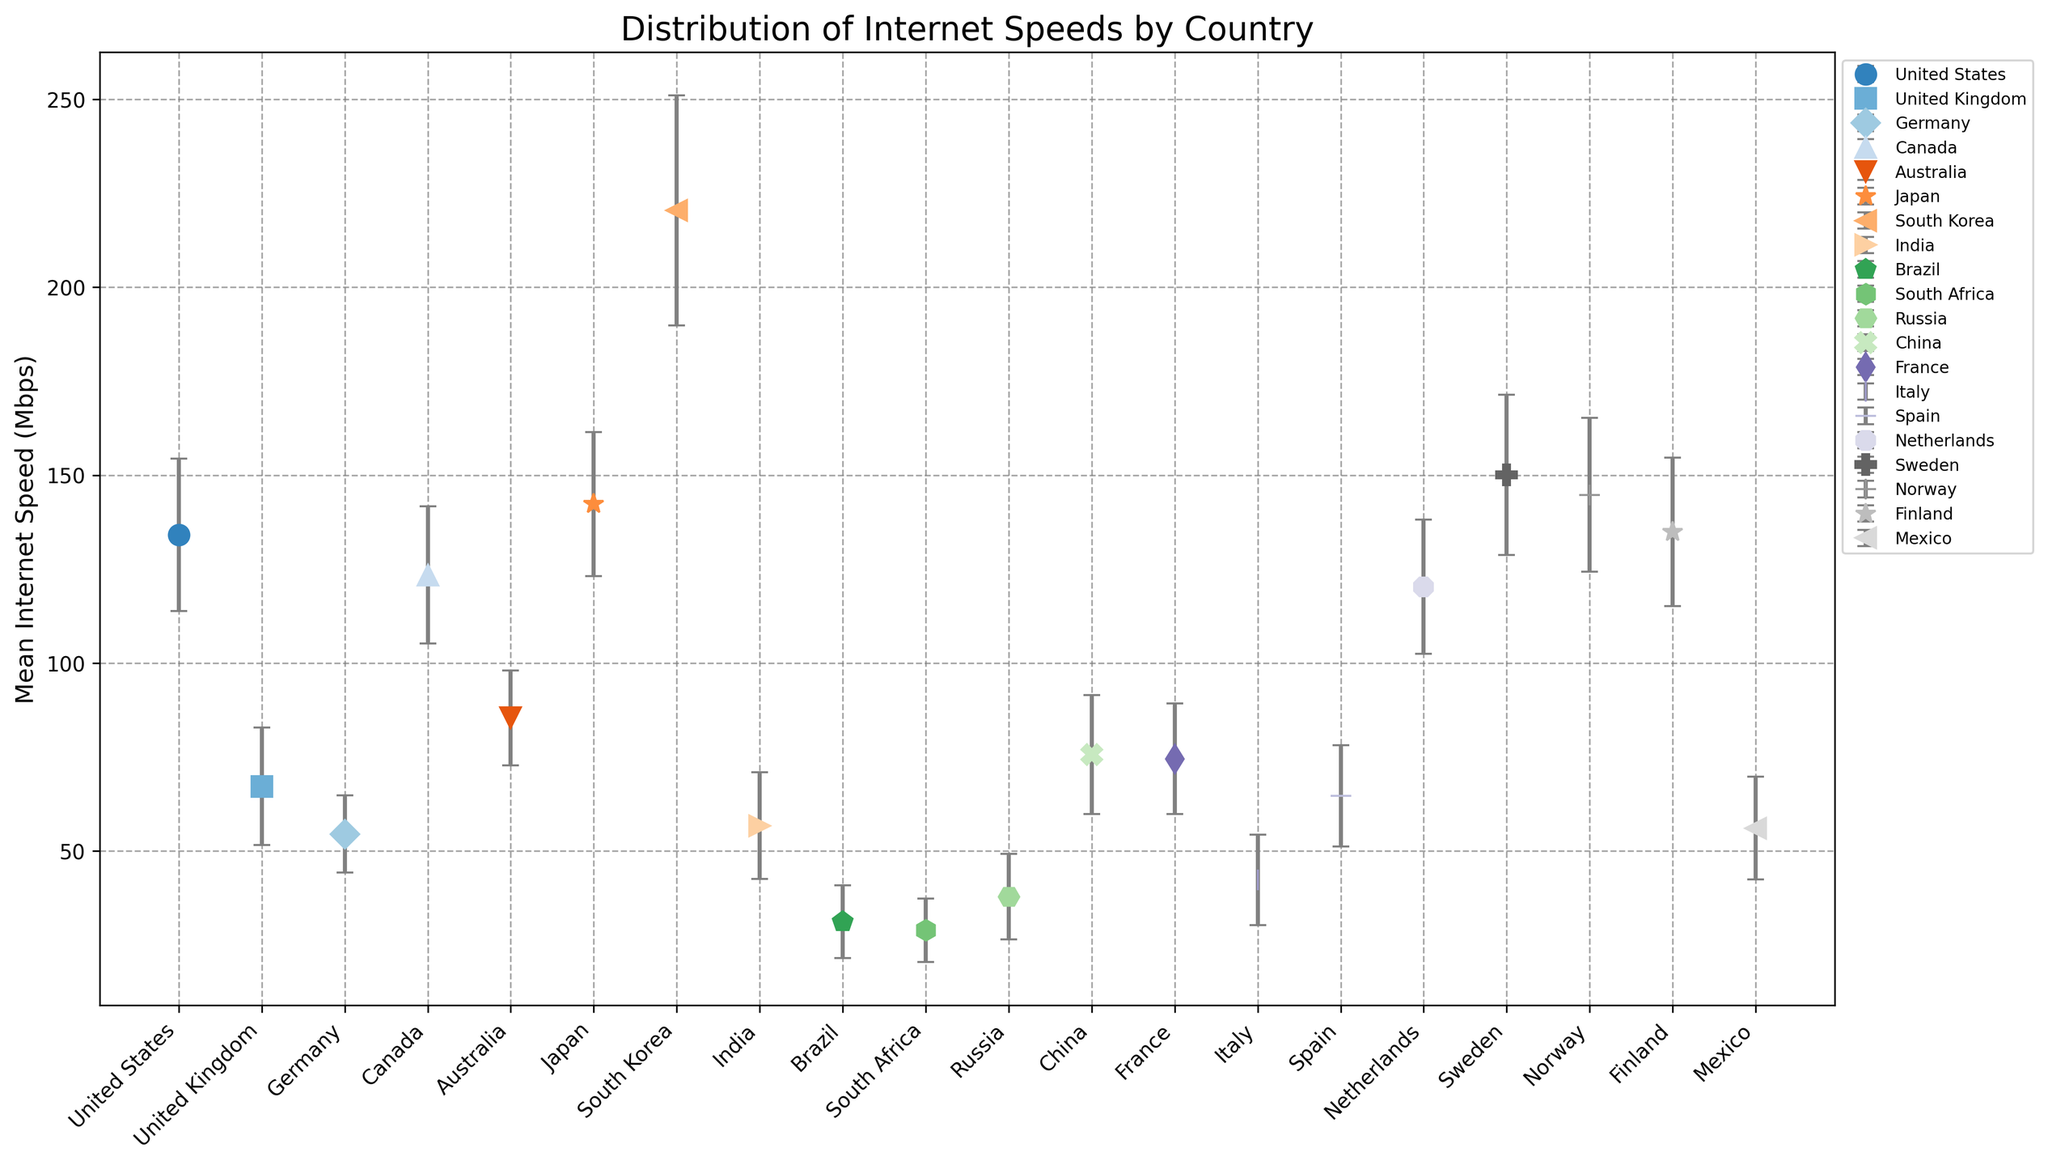Which country has the highest mean internet speed? The country with the highest mean internet speed is the one with the tallest point with error bars, representing its mean and standard deviation of internet speed. From the figure, this is South Korea.
Answer: South Korea Which two countries have mean internet speeds that differ by the smallest amount? To find this, look at the heights of all the points representing mean internet speeds and find the two closest points. From the figure, these appear to be China and France.
Answer: China and France What is the approximate range of internet speeds (mean ± standard deviation) for the United States? The range can be found by adding and subtracting the standard deviation from the mean internet speed. For the United States, this is approximately 134.14 ± 20.31, which translates to a range of 113.83 to 154.45 Mbps.
Answer: 113.83 to 154.45 Mbps How does the mean internet speed of Japan compare to that of Norway? Compare the heights of the points corresponding to Japan and Norway. The mean internet speed of Japan (142.33 Mbps) is slightly lower than that of Norway (144.78 Mbps).
Answer: Japan has a slightly lower mean internet speed than Norway Which country has the largest standard deviation in internet speed, and what could this imply about the reliability of its internet connections? The largest standard deviation can be identified by the longest error bar. South Korea has the largest standard deviation (30.56 Mbps). This implies that its internet speed is less reliable or more variable.
Answer: South Korea What is the total mean internet speed of Germany, Canada, and Australia combined? Sum the mean internet speeds of these three countries: Germany (54.56 Mbps), Canada (123.45 Mbps), and Australia (85.44 Mbps). The total is 54.56 + 123.45 + 85.44 = 263.45 Mbps.
Answer: 263.45 Mbps Which country has the lowest mean internet speed and what is its value? The country with the lowest mean internet speed is represented by the shortest point. This is South Africa with a mean internet speed of 28.95 Mbps.
Answer: South Africa, 28.95 Mbps Between the United Kingdom and Italy, which country has a higher internet speed variability? Compare the lengths of their error bars. The United Kingdom has a standard deviation of 15.67 Mbps, and Italy has 12.01 Mbps. Thus, the United Kingdom shows higher variability.
Answer: United Kingdom What is the difference in mean internet speed between Sweden and Brazil? Subtract the mean internet speed of Brazil from that of Sweden: 150.12 - 31.25 = 118.87 Mbps.
Answer: 118.87 Mbps How does the mean internet speed of China compare with that of France? Compare the heights of the points for China and France. Both appear to have very similar mean internet speeds; from the dataset, China has 75.67 Mbps and France has 74.56 Mbps.
Answer: China's mean internet speed is slightly higher than France's 